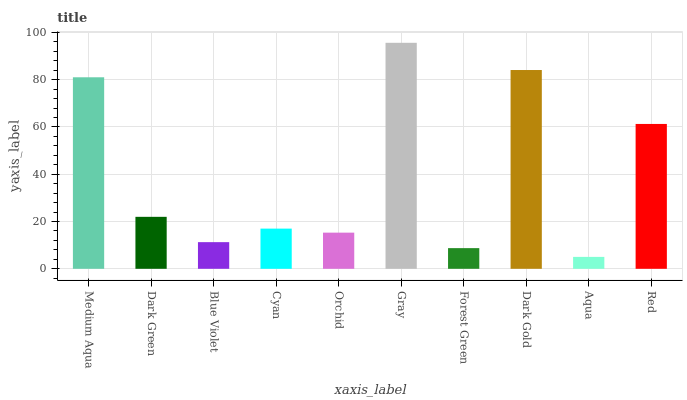Is Aqua the minimum?
Answer yes or no. Yes. Is Gray the maximum?
Answer yes or no. Yes. Is Dark Green the minimum?
Answer yes or no. No. Is Dark Green the maximum?
Answer yes or no. No. Is Medium Aqua greater than Dark Green?
Answer yes or no. Yes. Is Dark Green less than Medium Aqua?
Answer yes or no. Yes. Is Dark Green greater than Medium Aqua?
Answer yes or no. No. Is Medium Aqua less than Dark Green?
Answer yes or no. No. Is Dark Green the high median?
Answer yes or no. Yes. Is Cyan the low median?
Answer yes or no. Yes. Is Red the high median?
Answer yes or no. No. Is Blue Violet the low median?
Answer yes or no. No. 